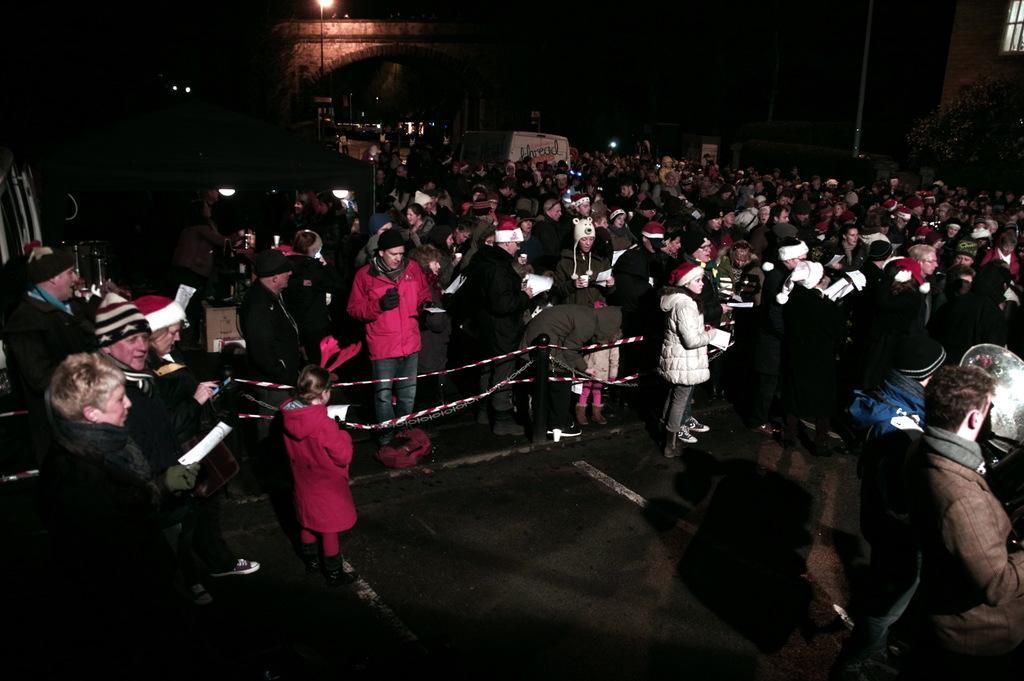Please provide a concise description of this image. In this picture we can see a group of people standing and some people holding the papers. In front of the people there are poles with ropes. Behind the people there is a vehicle's, bridge, tree, a building and the poles with a light. Behind the bridge there is a dark background. 